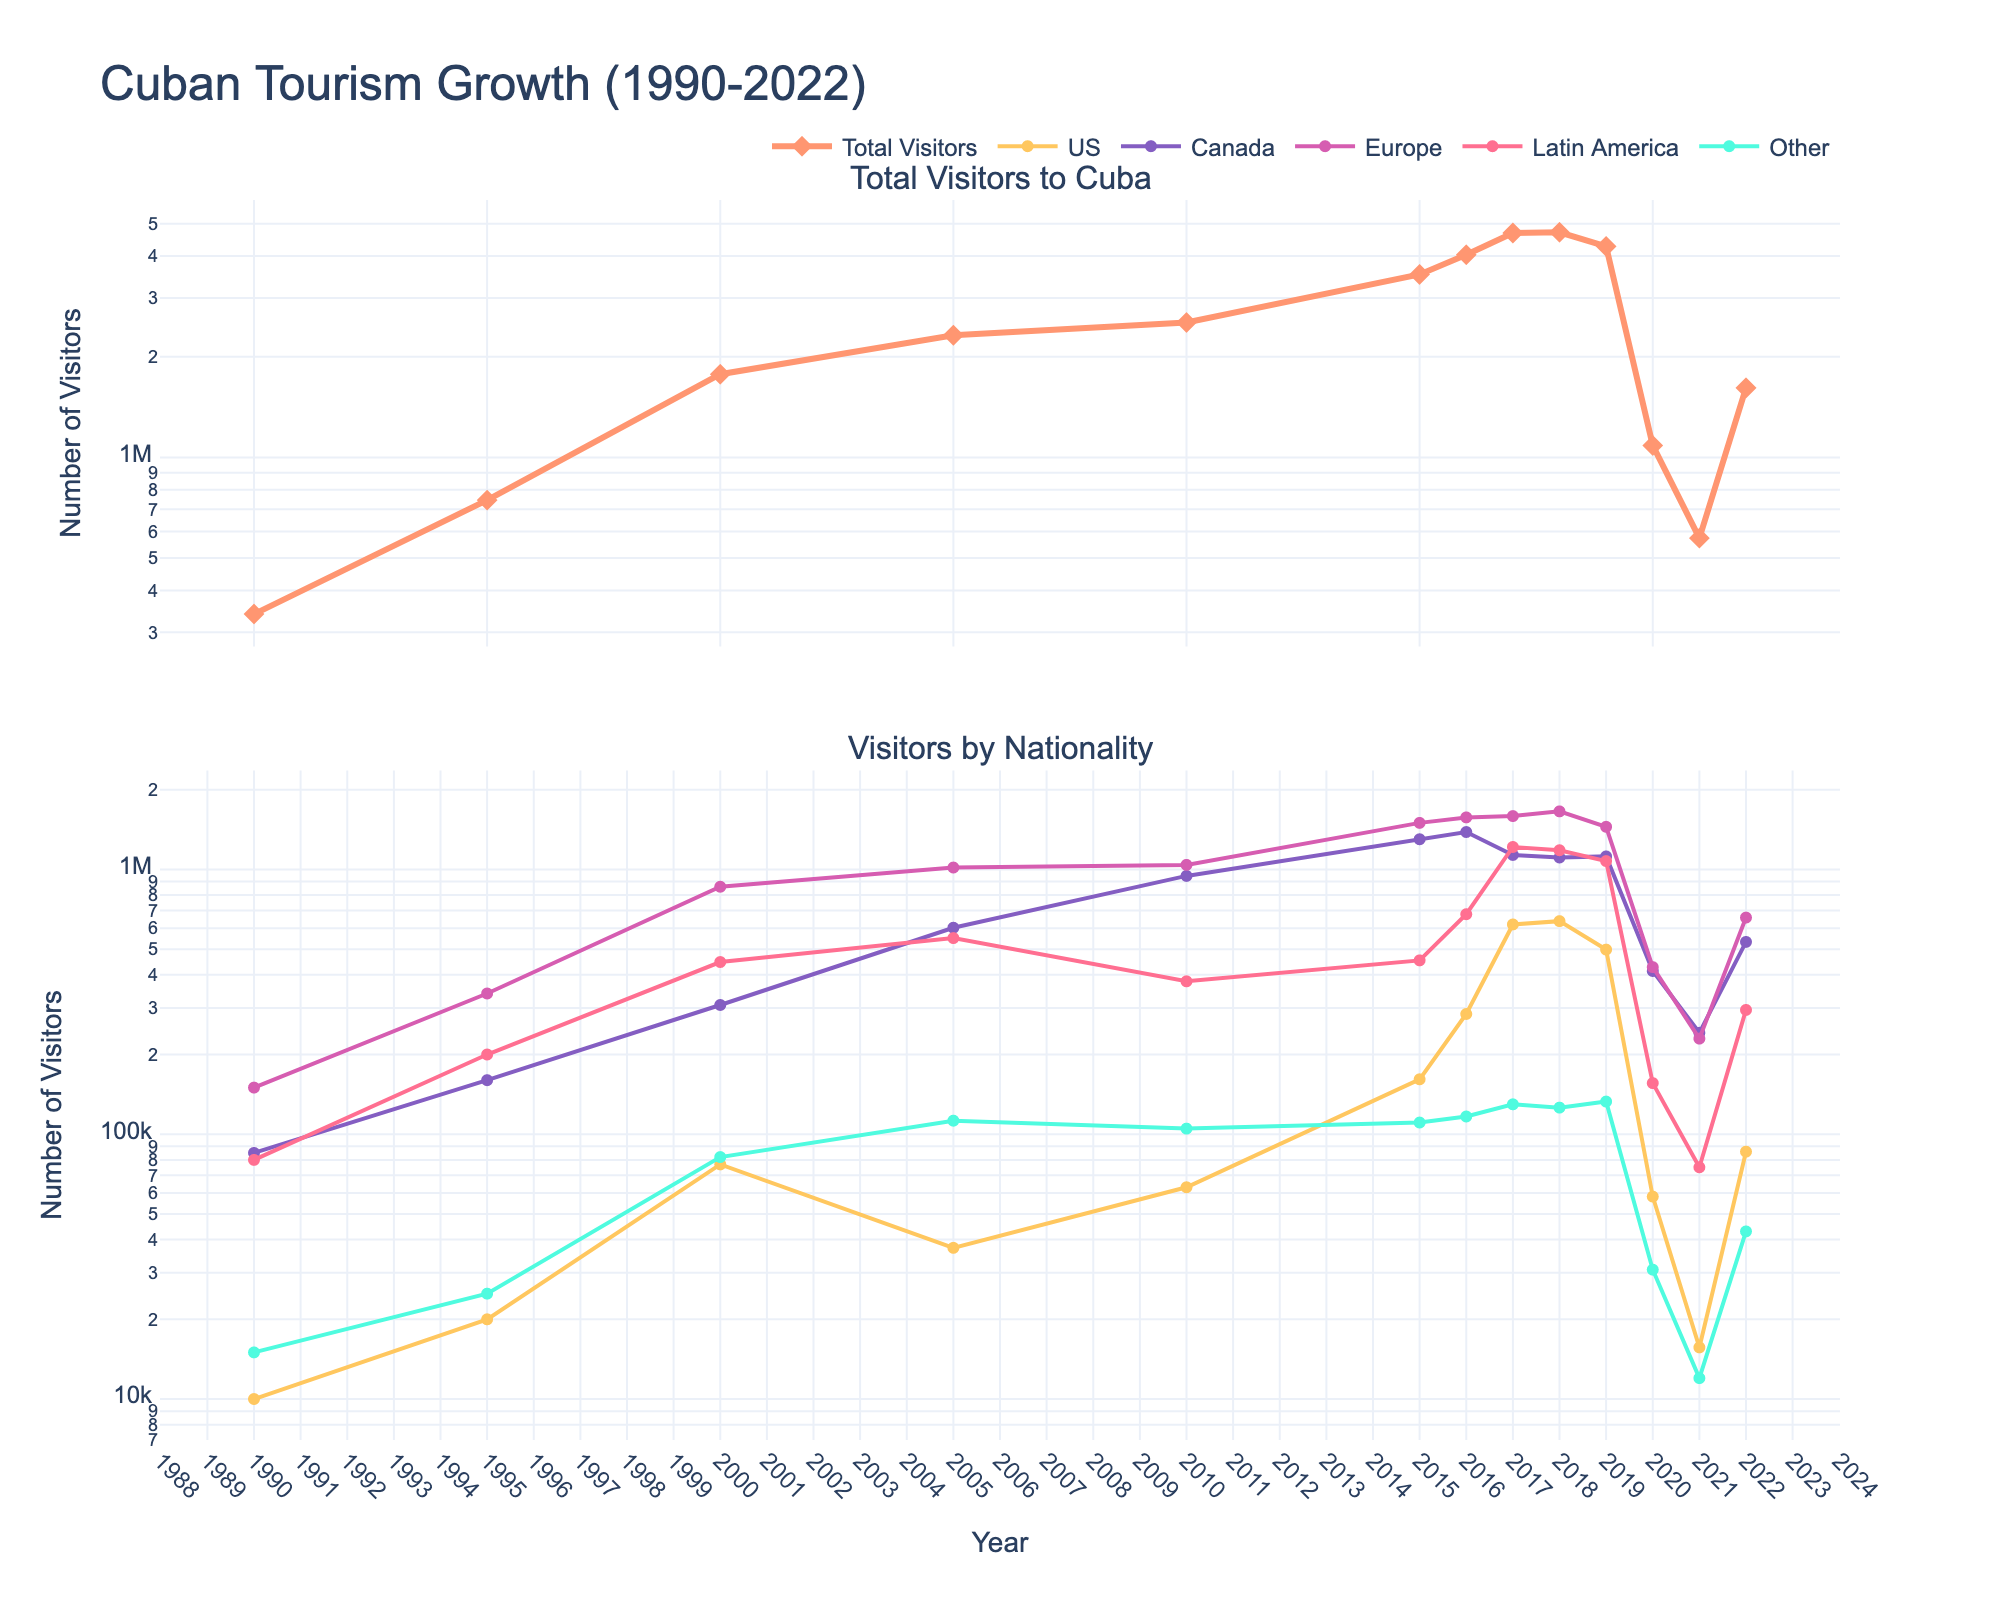What year saw the highest total number of visitors to Cuba? The highest total number of visitors can be spotted on the first graph where the peak is. According to the chart, the peak is in 2018.
Answer: 2018 Which nationality had the most significant increase in visitors from 2015 to 2016? By examining the second graph, we can compare the slopes for each nationality between 2015 and 2016. The US shows the steepest upward slope during this period.
Answer: US What was the total number of visitors from Canada in 2010 and 2015 combined? In the second graph, read the values for Canada in 2010 and 2015, and sum them up. For 2010 it is 945,248 and for 2015 it is 1,300,092. Summing these gives 945,248 + 1,300,092 = 2,245,340.
Answer: 2,245,340 Which nationality had consistently lower visitor numbers than others throughout the years? Observing the second graph, the category "Other" consistently has lower values compared to the other national groups listed.
Answer: Other Comparing 2019 to 2020, by what percentage did the total visitors to Cuba decrease? Calculate the difference between 2019 and 2020 total visitors, then compute the percentage: (4,275,558 - 1,085,920) / 4,275,558 * 100 ≈ 74.6%.
Answer: ≈ 74.6% In which year did visitors from Europe first surpass 1 million? Referring to the second graph, Europe's visitor trajectory first crosses the 1 million mark in 2000.
Answer: 2000 How did the total number of visitors change from 1990 to 2022? Using the first graph, note the total visitors in 1990 (340,000) and in 2022 (1,614,087). Subtract to find the change: 1,614,087 - 340,000 = 1,274,087.
Answer: 1,274,087 What is the trend in the number of visitors from the US from 1990 to 2010? Observing the US line in the second graph, visitors from the US generally increase from 1990 (10,000) to 2010 (63,046), albeit with fluctuations.
Answer: Increase Which nationality exceeded 1 million visitors the earliest? From the second graph, visitors from Europe exceeded 1 million in 2000, the earliest among the nationalities.
Answer: Europe Between which consecutive years did Latin America see the largest drop in visitor numbers? The steepest decline in the Latin America's line on the second graph occurs between 2019 and 2020.
Answer: 2019 to 2020 